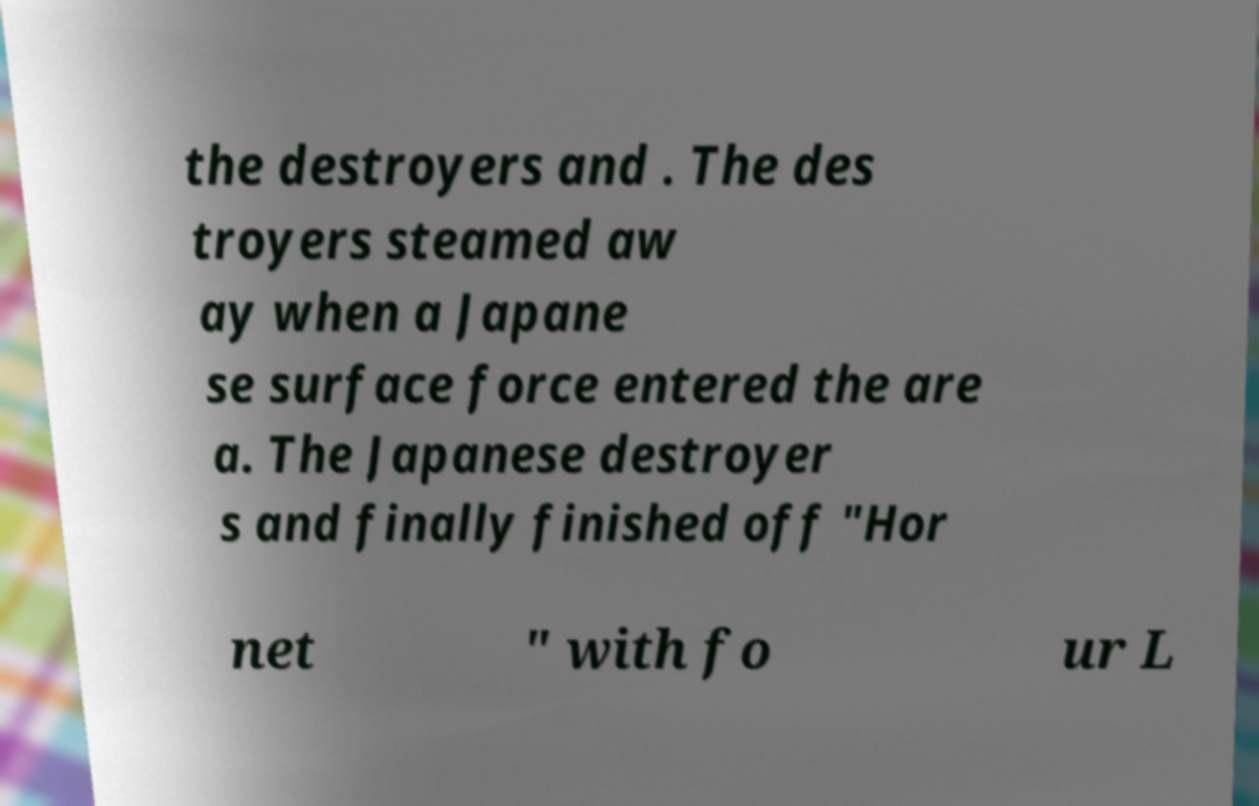I need the written content from this picture converted into text. Can you do that? the destroyers and . The des troyers steamed aw ay when a Japane se surface force entered the are a. The Japanese destroyer s and finally finished off "Hor net " with fo ur L 